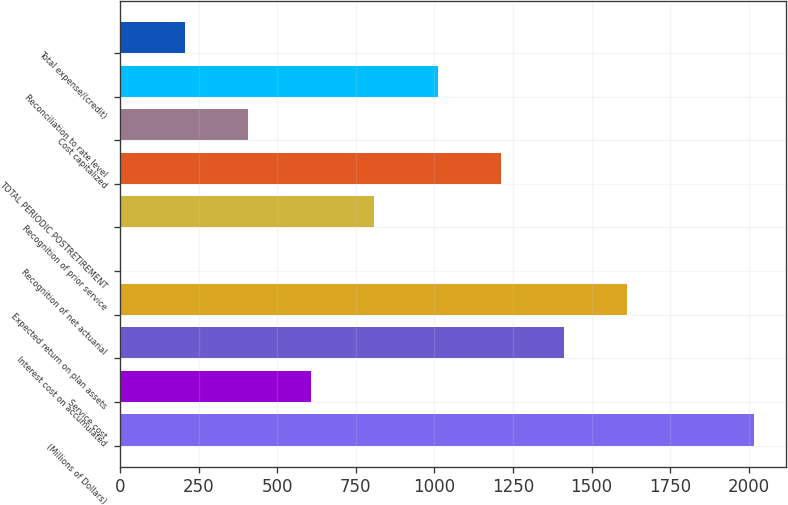<chart> <loc_0><loc_0><loc_500><loc_500><bar_chart><fcel>(Millions of Dollars)<fcel>Service cost<fcel>Interest cost on accumulated<fcel>Expected return on plan assets<fcel>Recognition of net actuarial<fcel>Recognition of prior service<fcel>TOTAL PERIODIC POSTRETIREMENT<fcel>Cost capitalized<fcel>Reconciliation to rate level<fcel>Total expense/(credit)<nl><fcel>2016<fcel>608.3<fcel>1412.7<fcel>1613.8<fcel>5<fcel>809.4<fcel>1211.6<fcel>407.2<fcel>1010.5<fcel>206.1<nl></chart> 